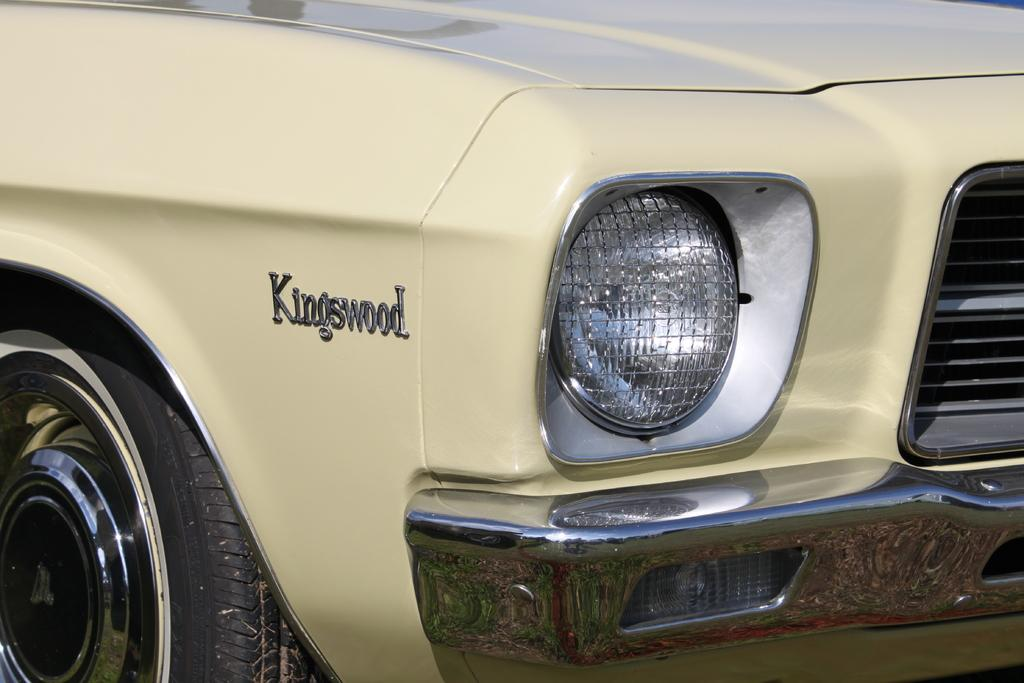What type of vehicle is present in the image? The image contains a car. What specific features of the car can be seen? The car's headlight, bumper, and a part of the tire are visible. What is the name of the car in the image? The car's name is "Kings Wood." What type of bread is being served on the table in the image? There is no table or bread present in the image; it features a car with specific details mentioned. 